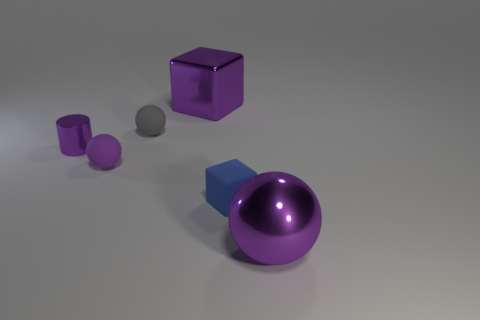How many other objects are there of the same color as the big metallic block?
Provide a succinct answer. 3. There is a thing behind the gray rubber object; what number of large objects are on the left side of it?
Give a very brief answer. 0. There is a rubber thing that is to the right of the big purple metal object behind the large thing right of the large block; what is its shape?
Your response must be concise. Cube. What is the size of the shiny ball?
Provide a succinct answer. Large. Are there any other cylinders that have the same material as the purple cylinder?
Keep it short and to the point. No. There is a purple rubber thing that is the same shape as the gray thing; what size is it?
Your answer should be very brief. Small. Is the number of purple shiny objects that are in front of the blue cube the same as the number of small purple rubber spheres?
Keep it short and to the point. Yes. There is a purple thing in front of the small purple ball; is its shape the same as the tiny purple matte thing?
Give a very brief answer. Yes. The blue rubber thing is what shape?
Provide a succinct answer. Cube. There is a cube that is behind the tiny matte object that is right of the big purple thing that is behind the large purple shiny ball; what is it made of?
Give a very brief answer. Metal. 